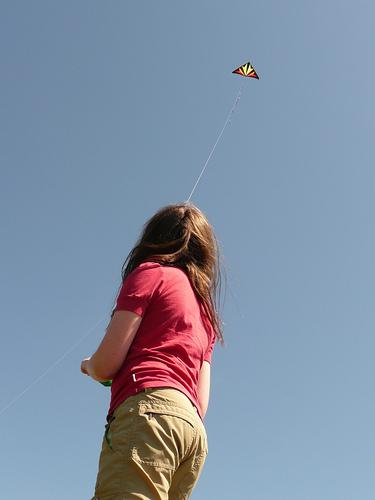Question: where is the photo taken?
Choices:
A. A museum.
B. Skate park.
C. Alley way.
D. At a park.
Answer with the letter. Answer: D Question: who is in this photo?
Choices:
A. A boy.
B. A woman.
C. A man.
D. A girl.
Answer with the letter. Answer: D Question: what is the girl wearing?
Choices:
A. A t shirt and pants.
B. A dress.
C. Tennis shoes.
D. A t shirt and shorts.
Answer with the letter. Answer: A Question: why is the girl looking up?
Choices:
A. She's looking at clouds.
B. She is flying a kite.
C. She's looking at a bird.
D. She's looking at a plane.
Answer with the letter. Answer: B 